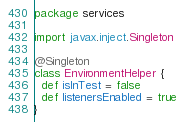<code> <loc_0><loc_0><loc_500><loc_500><_Scala_>package services

import javax.inject.Singleton

@Singleton
class EnvironmentHelper {
  def isInTest = false
  def listenersEnabled = true
}
</code> 